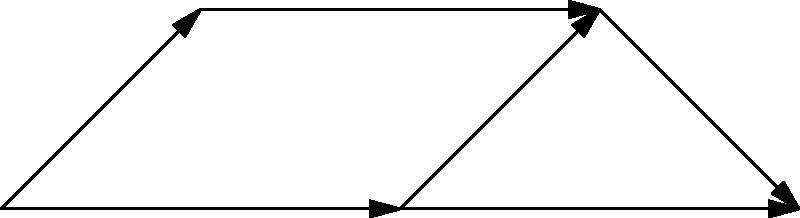Given the food web structure represented by the graph, calculate the first homology group $H_1$ of this simplicial complex. How does this result inform our understanding of the ecosystem's complexity and potential vulnerabilities? To calculate the first homology group $H_1$ and interpret its meaning for the food web structure, we'll follow these steps:

1. Identify the simplices:
   0-simplices (vertices): A, B, C, D, E
   1-simplices (edges): AB, AC, BD, CD, CE, DE

2. Calculate the chain groups:
   $C_0$ = 5 (number of vertices)
   $C_1$ = 6 (number of edges)
   $C_2$ = 0 (no 2-simplices/triangles)

3. Calculate the boundary maps:
   $\partial_1: C_1 \to C_0$
   $\partial_2: C_2 \to C_1$ (trivial, as $C_2 = 0$)

4. Find the kernel of $\partial_1$ (cycles):
   $ker(\partial_1) = \{AB-AC+CD-BD, CE-CD+DE\}$
   Rank = 2

5. Find the image of $\partial_2$ (boundaries):
   $im(\partial_2) = \{0\}$ (trivial)
   Rank = 0

6. Calculate $H_1$:
   $H_1 = ker(\partial_1) / im(\partial_2)$
   $H_1 \cong \mathbb{Z}^2$

7. Interpretation:
   - The first homology group $H_1 \cong \mathbb{Z}^2$ indicates two independent cycles in the food web.
   - These cycles represent circular dependencies or feedback loops in the ecosystem.
   - The presence of multiple cycles suggests a complex, interconnected system with potential for stability.
   - However, it also indicates potential vulnerabilities, as disruptions to key species could affect multiple pathways.
   - The rank of $H_1$ (2) quantifies the number of "holes" in the network, providing a measure of ecosystem complexity.

This topological analysis reveals important structural features of the food web, highlighting both its resilience and potential fragilities.
Answer: $H_1 \cong \mathbb{Z}^2$, indicating two independent cycles that represent ecosystem complexity and potential vulnerabilities. 